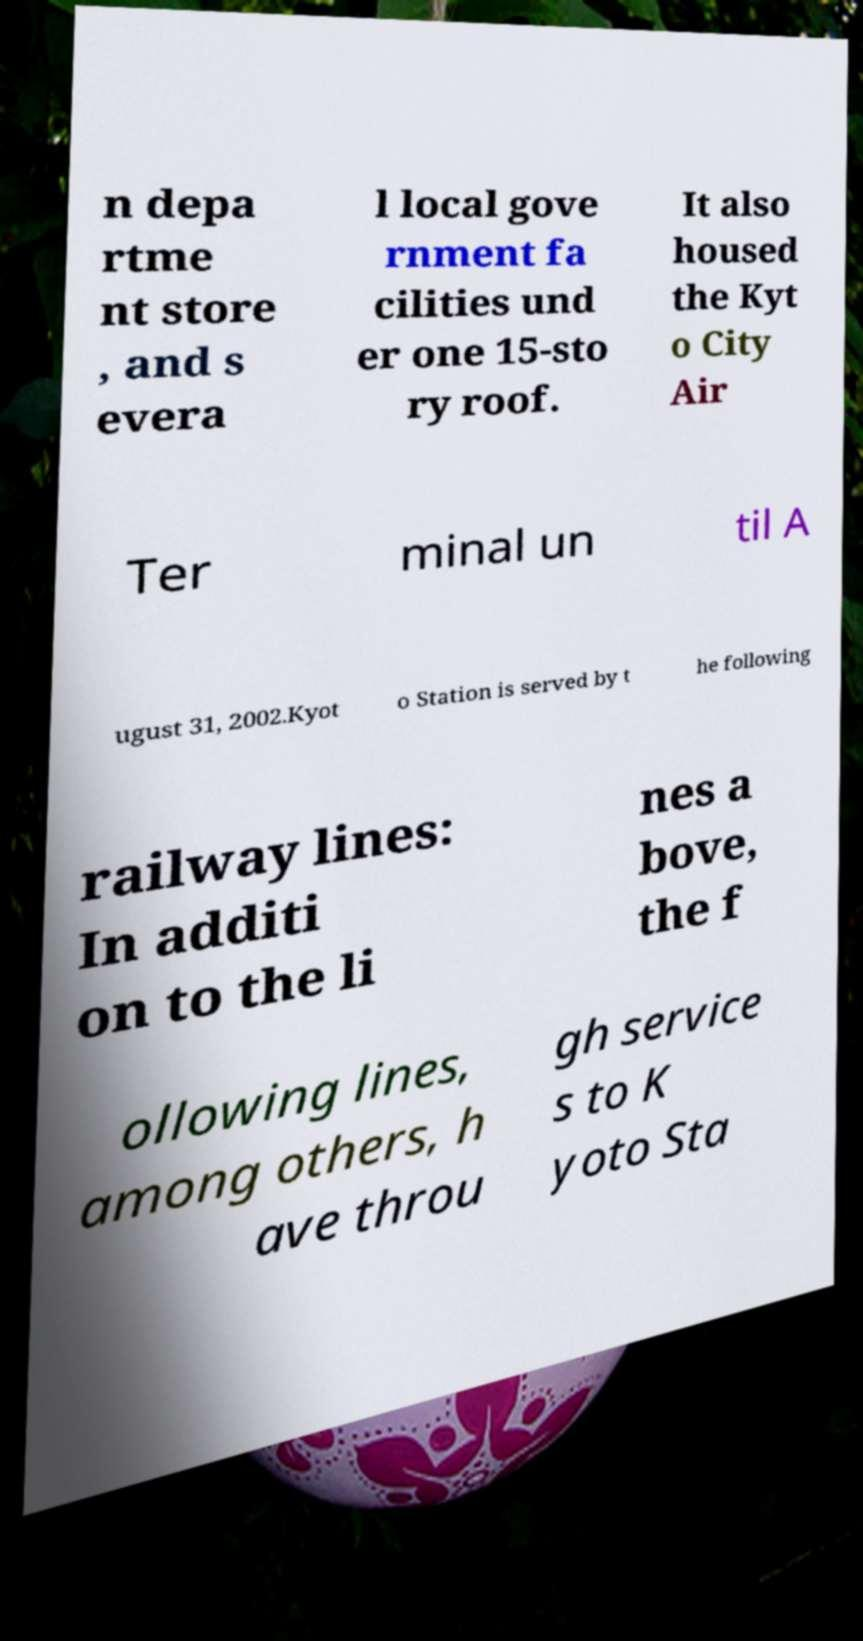Please identify and transcribe the text found in this image. n depa rtme nt store , and s evera l local gove rnment fa cilities und er one 15-sto ry roof. It also housed the Kyt o City Air Ter minal un til A ugust 31, 2002.Kyot o Station is served by t he following railway lines: In additi on to the li nes a bove, the f ollowing lines, among others, h ave throu gh service s to K yoto Sta 